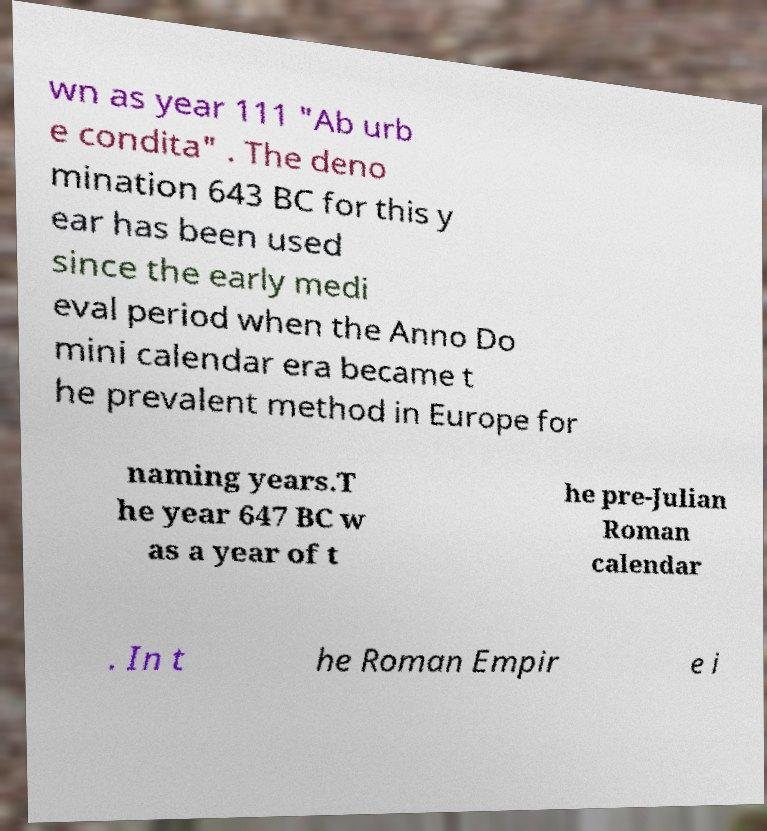Can you read and provide the text displayed in the image?This photo seems to have some interesting text. Can you extract and type it out for me? wn as year 111 "Ab urb e condita" . The deno mination 643 BC for this y ear has been used since the early medi eval period when the Anno Do mini calendar era became t he prevalent method in Europe for naming years.T he year 647 BC w as a year of t he pre-Julian Roman calendar . In t he Roman Empir e i 